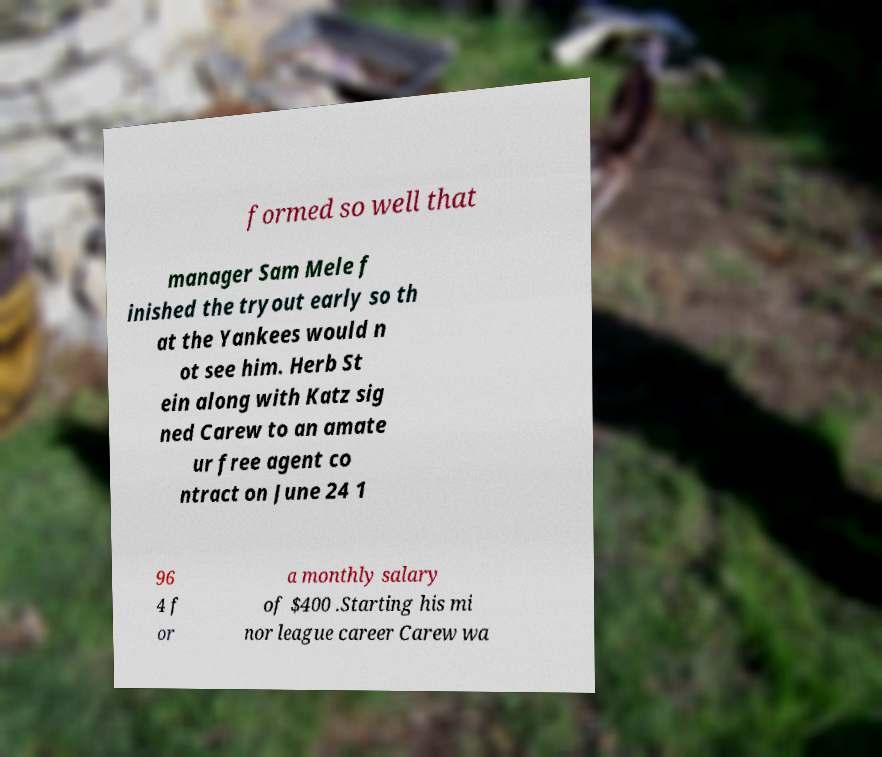Can you accurately transcribe the text from the provided image for me? formed so well that manager Sam Mele f inished the tryout early so th at the Yankees would n ot see him. Herb St ein along with Katz sig ned Carew to an amate ur free agent co ntract on June 24 1 96 4 f or a monthly salary of $400 .Starting his mi nor league career Carew wa 